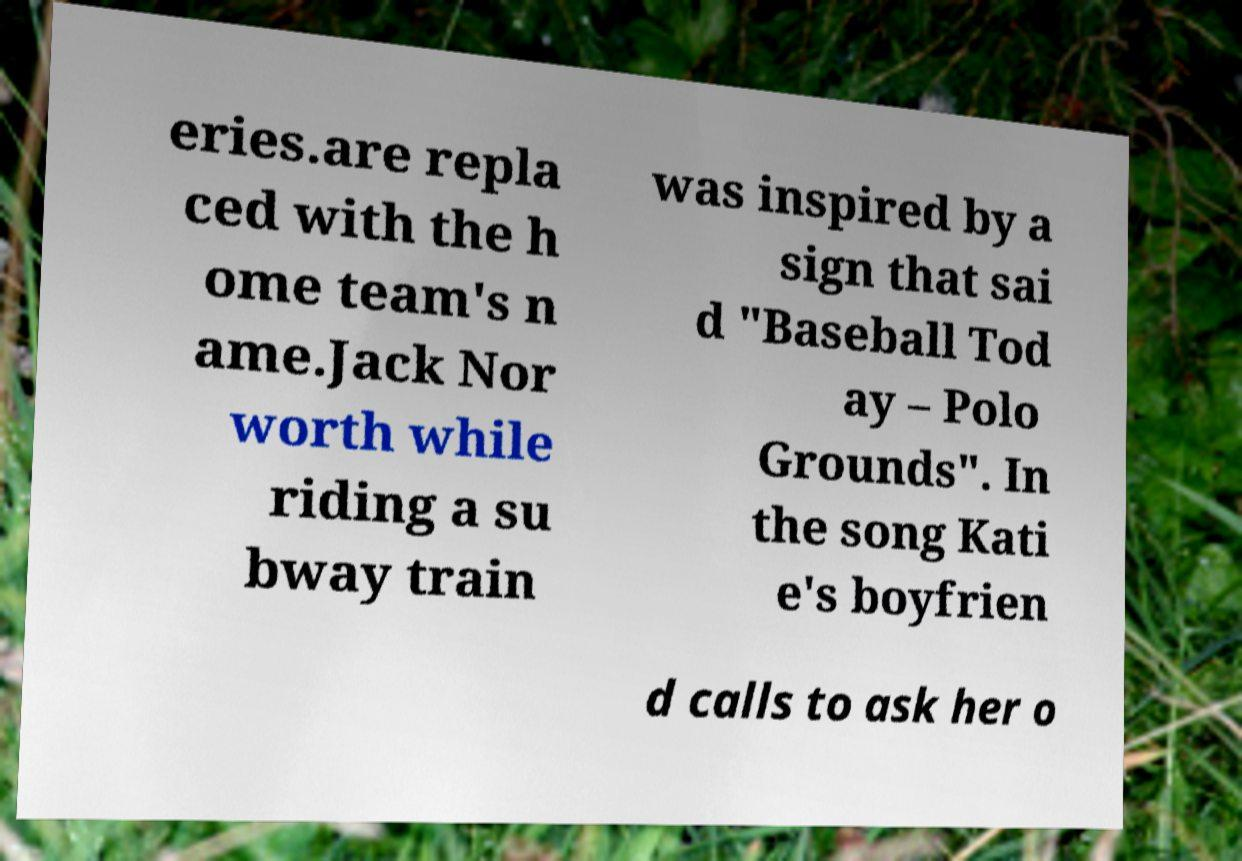There's text embedded in this image that I need extracted. Can you transcribe it verbatim? eries.are repla ced with the h ome team's n ame.Jack Nor worth while riding a su bway train was inspired by a sign that sai d "Baseball Tod ay – Polo Grounds". In the song Kati e's boyfrien d calls to ask her o 